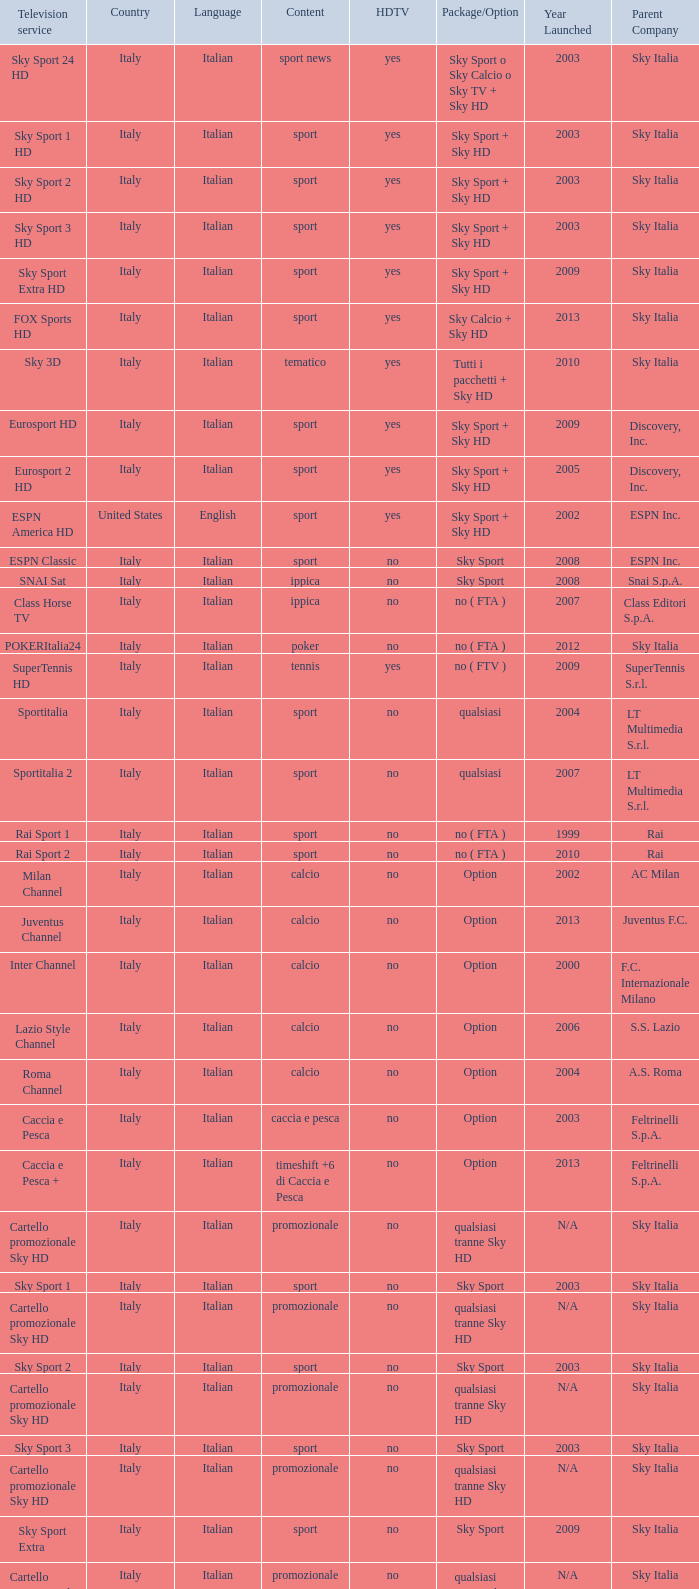When the television service is eurosport 2, what country does it belong to? Italy. 